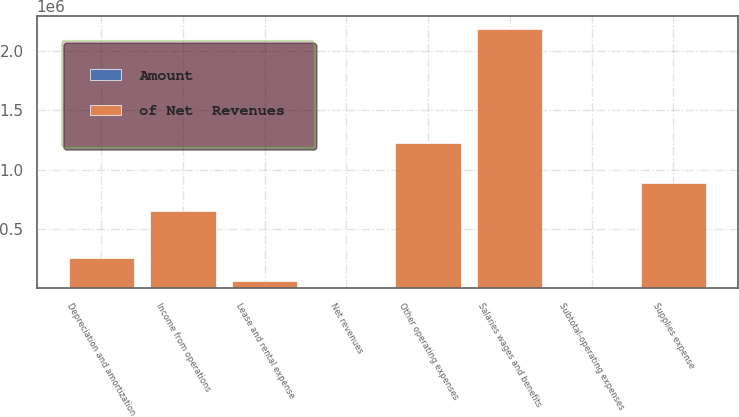<chart> <loc_0><loc_0><loc_500><loc_500><stacked_bar_chart><ecel><fcel>Net revenues<fcel>Salaries wages and benefits<fcel>Other operating expenses<fcel>Supplies expense<fcel>Depreciation and amortization<fcel>Lease and rental expense<fcel>Subtotal-operating expenses<fcel>Income from operations<nl><fcel>of Net  Revenues<fcel>93.85<fcel>2.18739e+06<fcel>1.22549e+06<fcel>886829<fcel>252365<fcel>55915<fcel>93.85<fcel>646994<nl><fcel>Amount<fcel>100<fcel>41.6<fcel>23.3<fcel>16.9<fcel>4.8<fcel>1.1<fcel>87.7<fcel>12.3<nl></chart> 